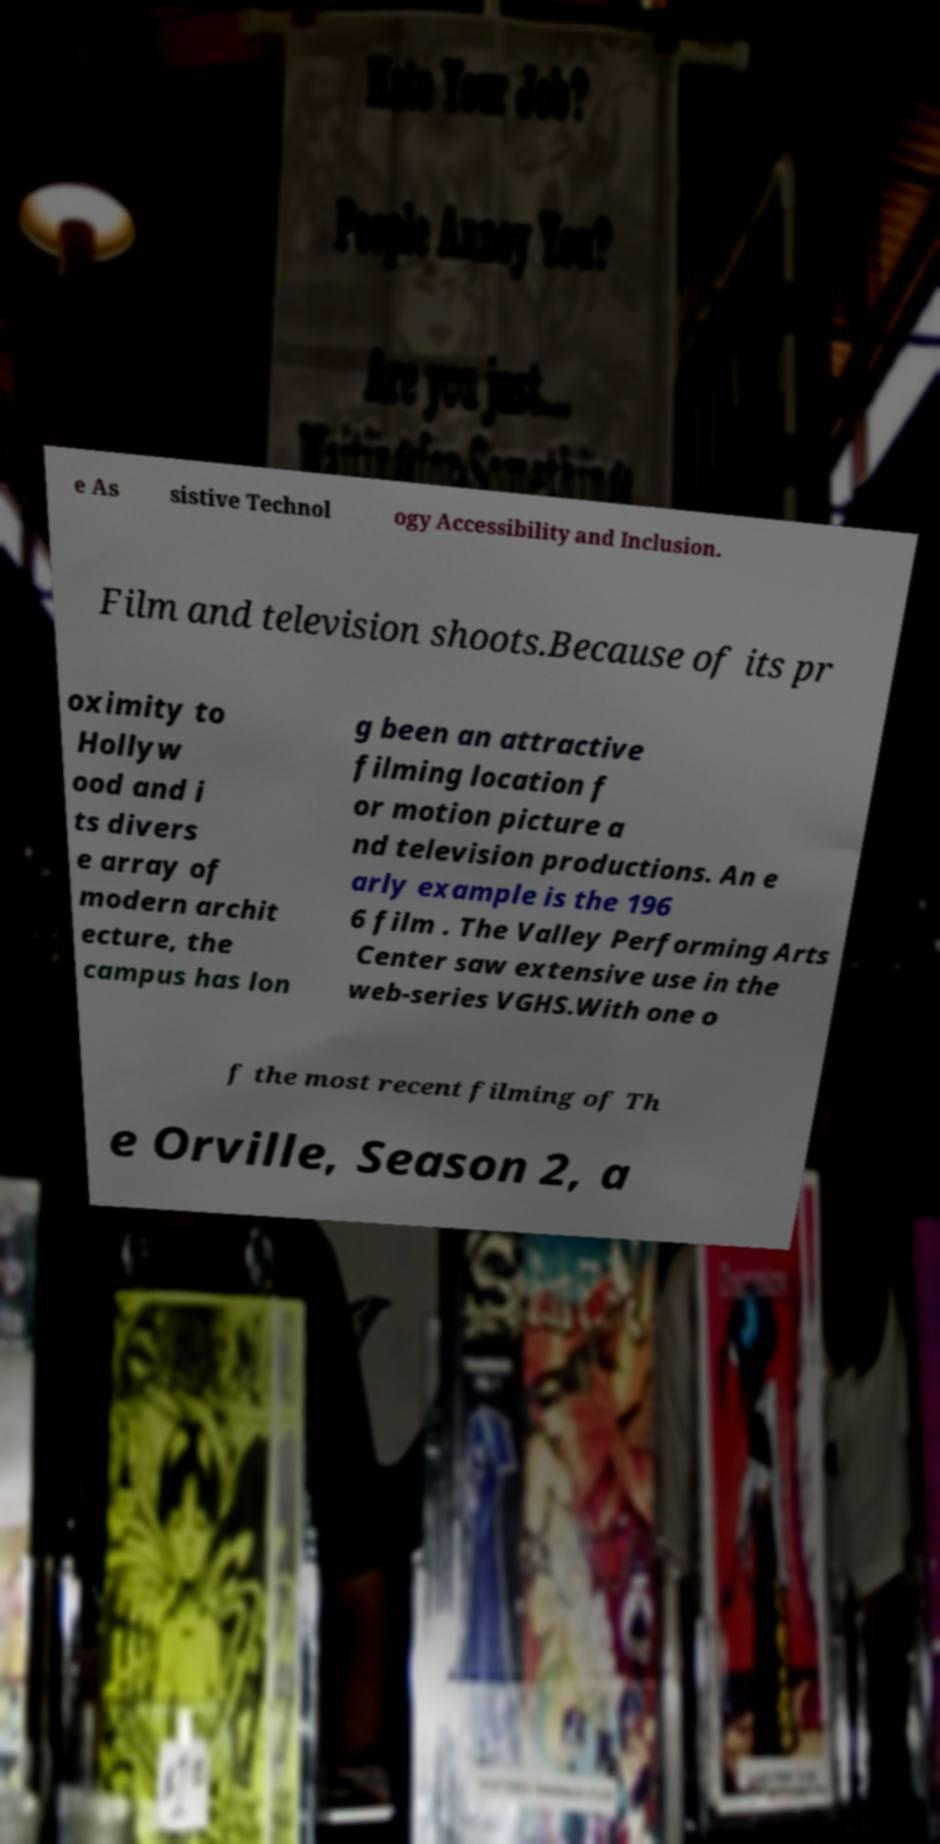I need the written content from this picture converted into text. Can you do that? e As sistive Technol ogy Accessibility and Inclusion. Film and television shoots.Because of its pr oximity to Hollyw ood and i ts divers e array of modern archit ecture, the campus has lon g been an attractive filming location f or motion picture a nd television productions. An e arly example is the 196 6 film . The Valley Performing Arts Center saw extensive use in the web-series VGHS.With one o f the most recent filming of Th e Orville, Season 2, a 